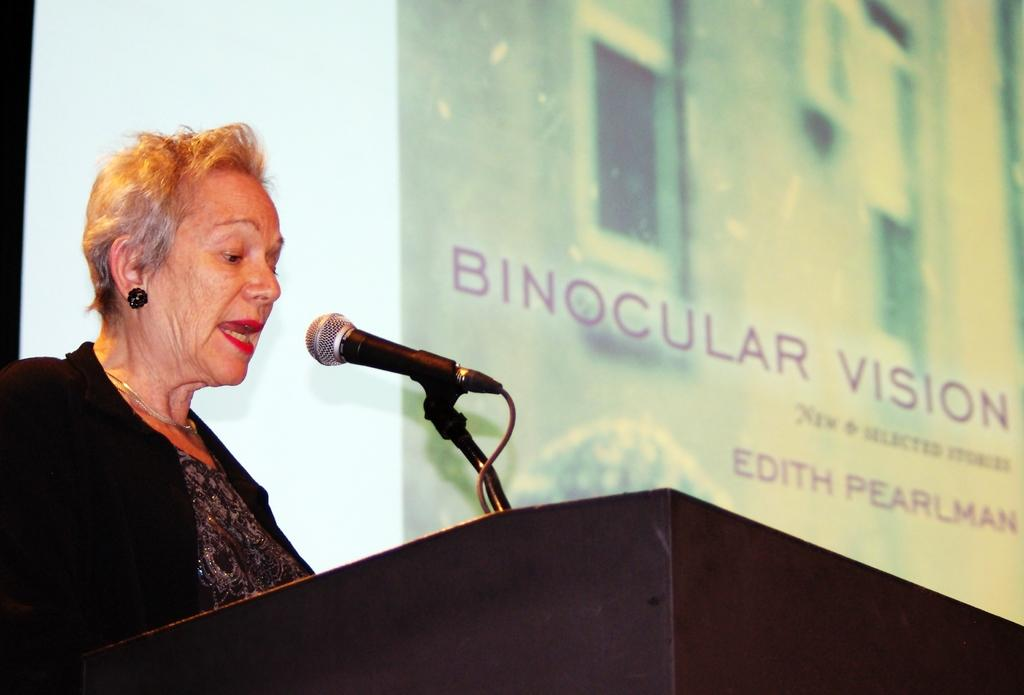What is the woman near in the image? The woman is standing near a podium in the image. What is the woman doing near the podium? The woman is talking near the podium. What is attached to the podium? There is a microphone attached to the podium. What can be seen on the big banner in the image? The big banner in the image has an image and text. What type of breakfast is being served in the image? There is no breakfast visible in the image. Can you describe the ocean in the image? There is no ocean present in the image. 